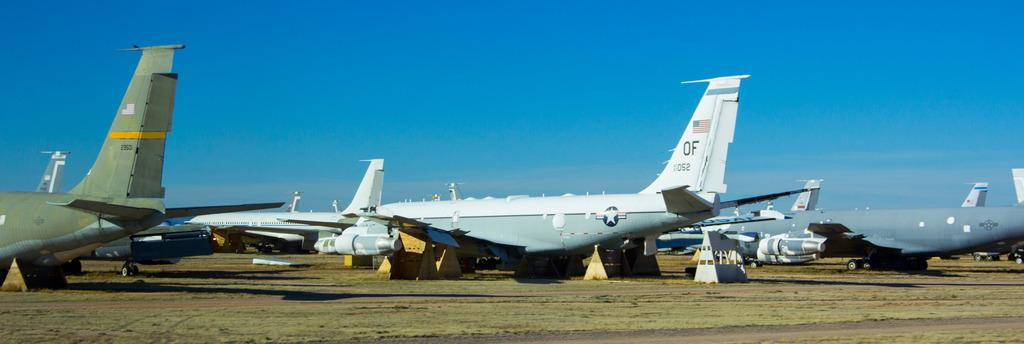What is the main subject of the image? The main subject of the image is aeroplanes on the ground. What can be seen in the background of the image? The sky is visible in the background of the image. What is the condition of the sky in the image? Clouds are present in the sky. Reasoning: Let' Let's think step by step in order to produce the conversation. We start by identifying the main subject of the image, which is the aeroplanes on the ground. Next, we describe the background of the image, which is the sky. Finally, we provide more detail about the sky by mentioning the presence of clouds. Absurd Question/Answer: What type of garden can be seen in the image? There is no garden present in the image; it features aeroplanes on the ground and a sky with clouds. What type of garden can be seen in the image? There is no garden present in the image; it features aeroplanes on the ground and a sky with clouds. 